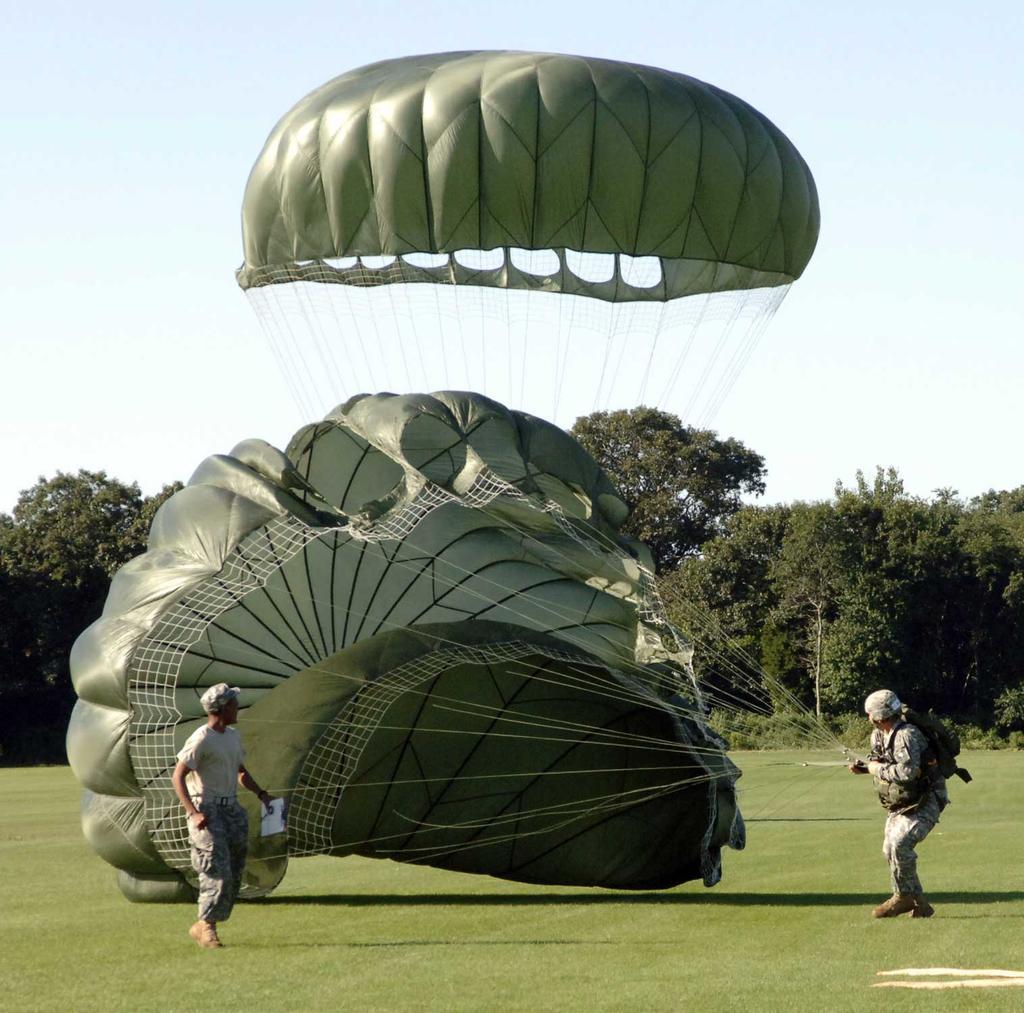In one or two sentences, can you explain what this image depicts? In the picture I can see a person wearing a dress, cap and shoes is carrying a backpack and holding the ropes of the parachute and this person is walking on the grass. In the background, I can see trees and the sky. 